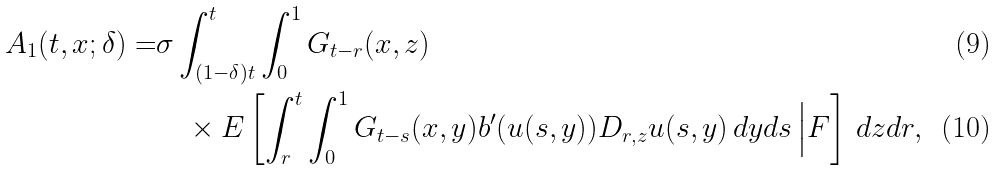<formula> <loc_0><loc_0><loc_500><loc_500>A _ { 1 } ( t , x ; \delta ) = & \sigma \int _ { ( 1 - \delta ) t } ^ { t } \int _ { 0 } ^ { 1 } G _ { t - r } ( x , z ) \\ & \quad \times E \left [ \int _ { r } ^ { t } \int _ { 0 } ^ { 1 } G _ { t - s } ( x , y ) b ^ { \prime } ( u ( s , y ) ) D _ { r , z } u ( s , y ) \, d y d s \, \Big | F \right ] \, d z d r ,</formula> 